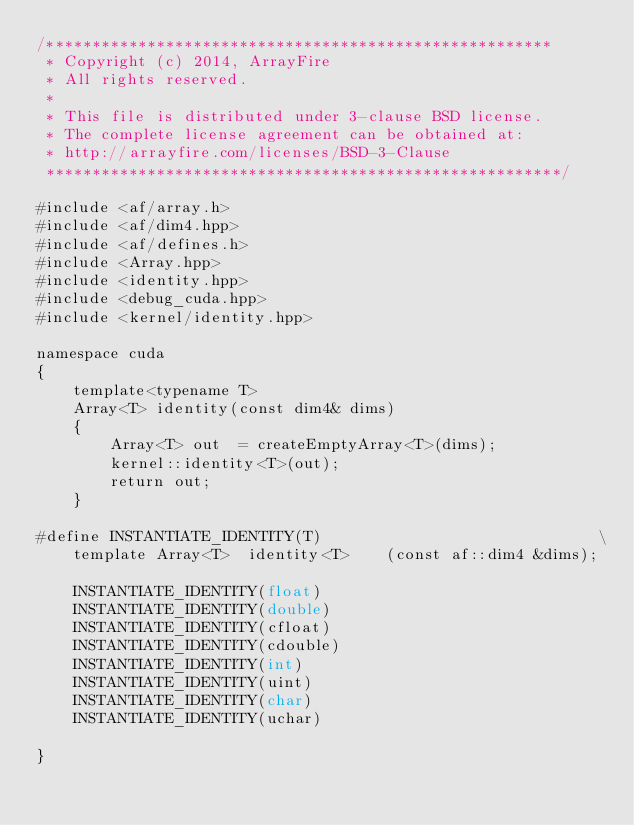<code> <loc_0><loc_0><loc_500><loc_500><_Cuda_>/*******************************************************
 * Copyright (c) 2014, ArrayFire
 * All rights reserved.
 *
 * This file is distributed under 3-clause BSD license.
 * The complete license agreement can be obtained at:
 * http://arrayfire.com/licenses/BSD-3-Clause
 ********************************************************/

#include <af/array.h>
#include <af/dim4.hpp>
#include <af/defines.h>
#include <Array.hpp>
#include <identity.hpp>
#include <debug_cuda.hpp>
#include <kernel/identity.hpp>

namespace cuda
{
    template<typename T>
    Array<T> identity(const dim4& dims)
    {
        Array<T> out  = createEmptyArray<T>(dims);
        kernel::identity<T>(out);
        return out;
    }

#define INSTANTIATE_IDENTITY(T)                              \
    template Array<T>  identity<T>    (const af::dim4 &dims);

    INSTANTIATE_IDENTITY(float)
    INSTANTIATE_IDENTITY(double)
    INSTANTIATE_IDENTITY(cfloat)
    INSTANTIATE_IDENTITY(cdouble)
    INSTANTIATE_IDENTITY(int)
    INSTANTIATE_IDENTITY(uint)
    INSTANTIATE_IDENTITY(char)
    INSTANTIATE_IDENTITY(uchar)

}
</code> 